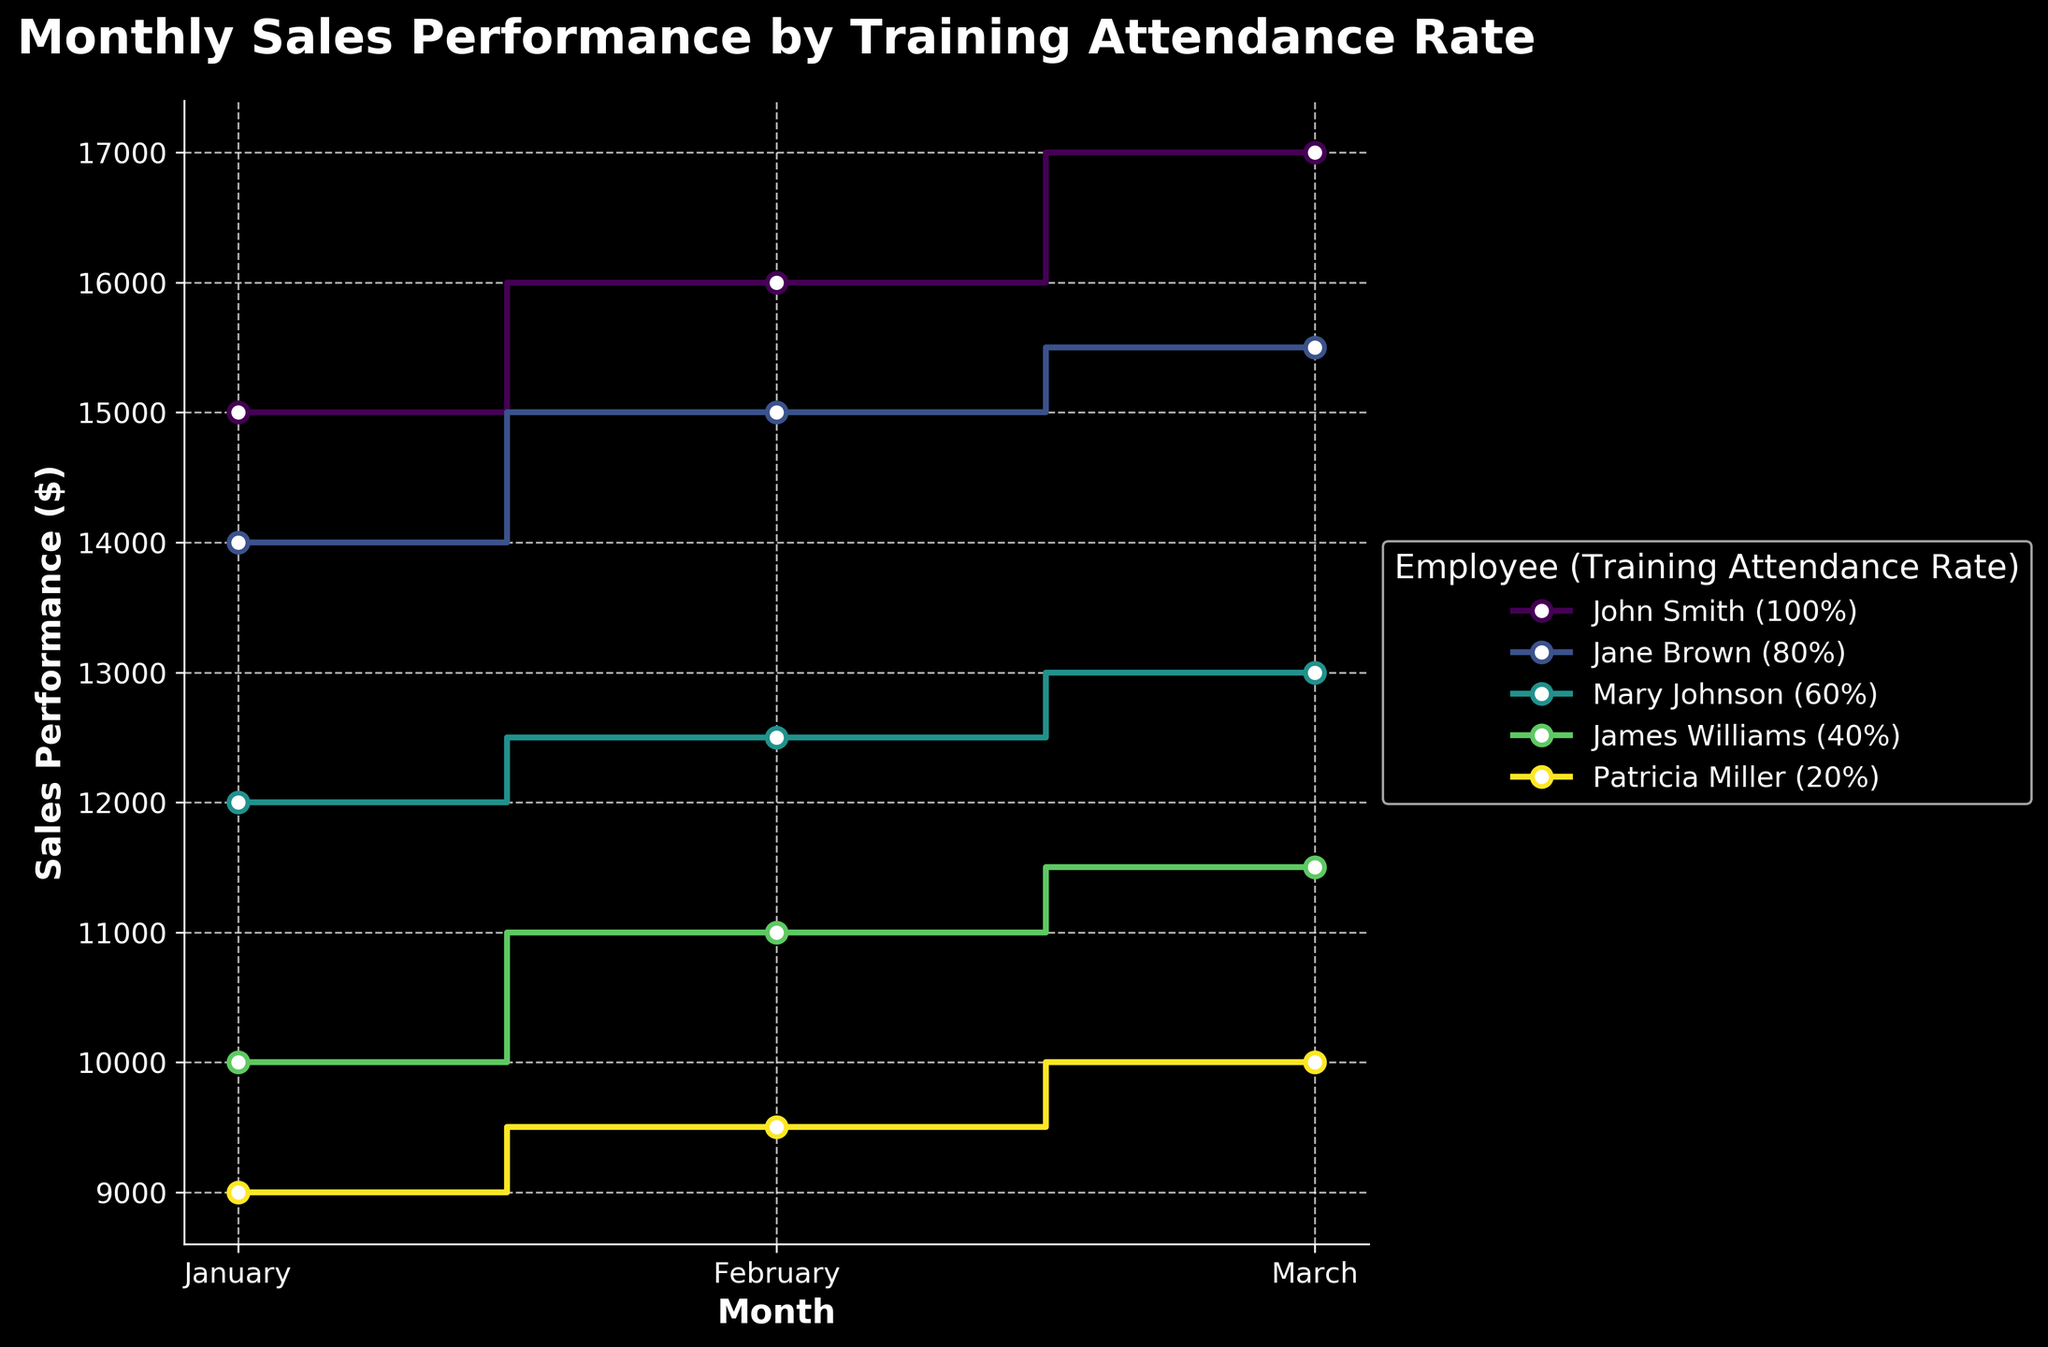What is the title of the figure? The title can be found at the top of the figure. It reads "Monthly Sales Performance by Training Attendance Rate".
Answer: Monthly Sales Performance by Training Attendance Rate Which employee had the highest sales performance in February? By inspecting the February data points, John Smith had the highest sales performance at $16,000.
Answer: John Smith How much did Jane Brown's sales performance increase from January to March? Jane Brown’s sales were $14,000 in January and $15,500 in March. The increase is $15,500 - $14,000 = $1,500.
Answer: $1,500 Who has the lowest training attendance rate, and how does their sales performance in March compare to others'? Patricia Miller has the lowest training attendance rate (20%). Her sales performance in March is $10,000, which is the lowest in comparison to other employees' sales in that month.
Answer: Patricia Miller, lowest in March What is John Smith's average monthly sales performance? John Smith’s sales performances are $15,000, $16,000, and $17,000 in January, February, and March respectively. The average is ($15,000 + $16,000 + $17,000) / 3 = $16,000.
Answer: $16,000 How does Mary Johnson's February sales performance compare to James Williams' sales performance in the same month? Mary Johnson’s February sales are $12,500 while James Williams’ are $11,000. Thus, Mary Johnson’s performance is higher.
Answer: Mary Johnson's is higher Which month had the highest overall sales performance across all employees? By comparing all months, March shows the highest individual sales performances (all employees' data points are increasing towards March).
Answer: March Does attending more training correlate with higher sales performance? Observing the stair steps: John Smith (100% attendance) has the highest sales, followed by Jane Brown (80%), showing a positive correlation between higher training attendance and sales.
Answer: Yes What is the difference in sales performance between the highest and lowest performers in March? The highest performer in March is John Smith ($17,000) and the lowest is Patricia Miller ($10,000). The difference is $17,000 - $10,000 = $7,000.
Answer: $7,000 How does the sales performance trend of Jane Brown compare from January to March? Jane Brown’s sales performance increases steadily each month from $14,000 in January to $15,500 in March.
Answer: Steadily increases 